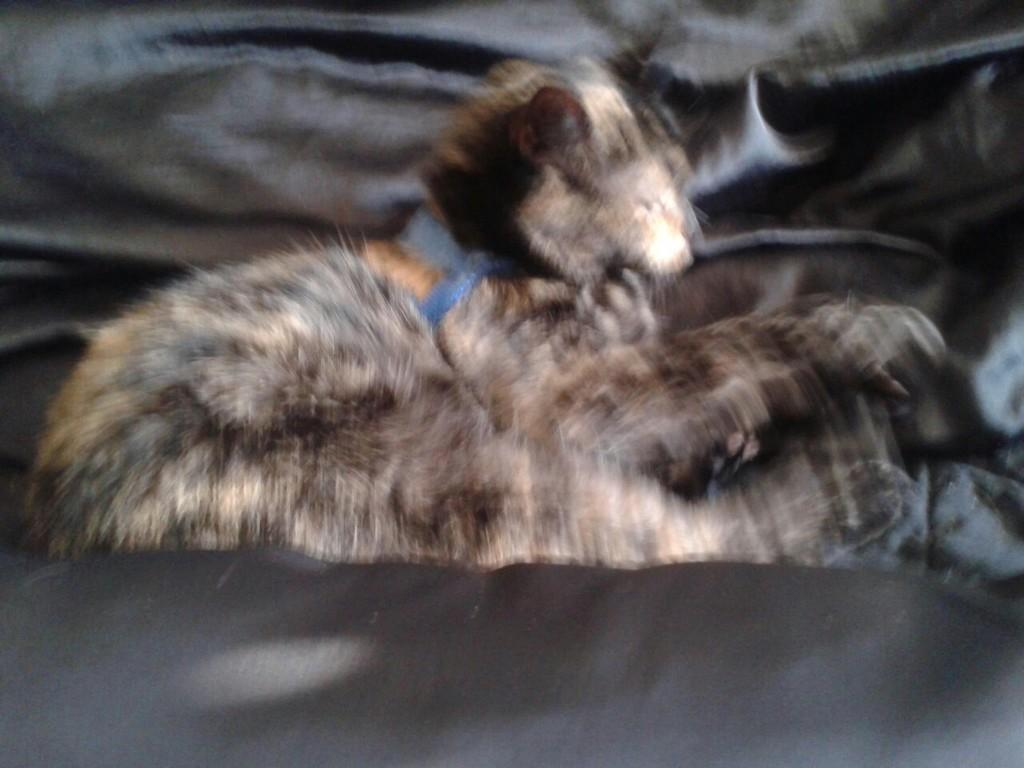What type of creature can be seen in the image? There is an animal in the image. Can you describe the quality of the image? The image is blurred. What credit score is required to view the image? There is no credit score requirement to view the image, as it is not a financial document or service. 